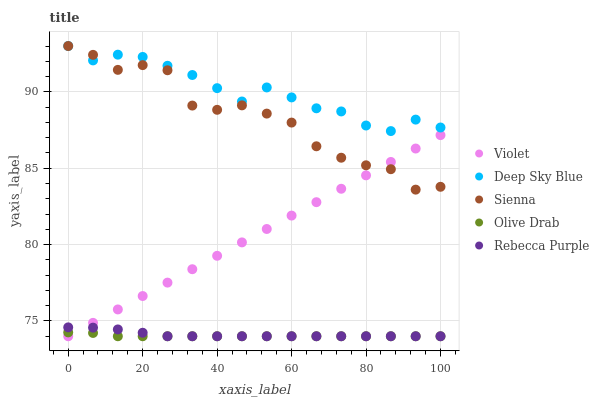Does Olive Drab have the minimum area under the curve?
Answer yes or no. Yes. Does Deep Sky Blue have the maximum area under the curve?
Answer yes or no. Yes. Does Rebecca Purple have the minimum area under the curve?
Answer yes or no. No. Does Rebecca Purple have the maximum area under the curve?
Answer yes or no. No. Is Violet the smoothest?
Answer yes or no. Yes. Is Sienna the roughest?
Answer yes or no. Yes. Is Rebecca Purple the smoothest?
Answer yes or no. No. Is Rebecca Purple the roughest?
Answer yes or no. No. Does Rebecca Purple have the lowest value?
Answer yes or no. Yes. Does Deep Sky Blue have the lowest value?
Answer yes or no. No. Does Deep Sky Blue have the highest value?
Answer yes or no. Yes. Does Rebecca Purple have the highest value?
Answer yes or no. No. Is Olive Drab less than Sienna?
Answer yes or no. Yes. Is Deep Sky Blue greater than Rebecca Purple?
Answer yes or no. Yes. Does Deep Sky Blue intersect Sienna?
Answer yes or no. Yes. Is Deep Sky Blue less than Sienna?
Answer yes or no. No. Is Deep Sky Blue greater than Sienna?
Answer yes or no. No. Does Olive Drab intersect Sienna?
Answer yes or no. No. 